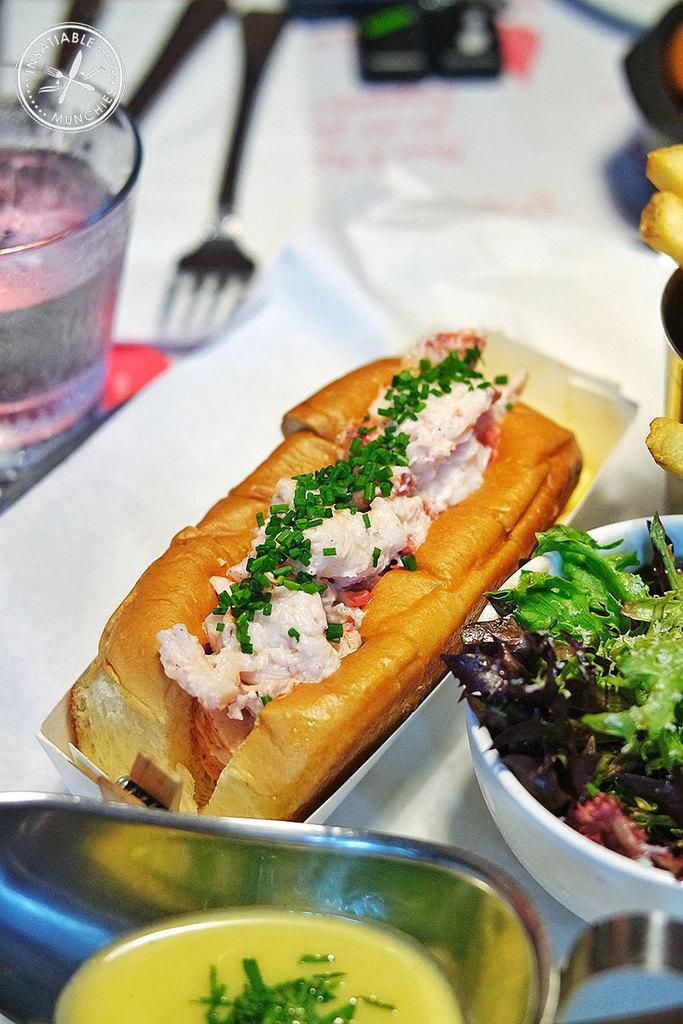How would you summarize this image in a sentence or two? In this picture I can see some food item kept on the table. 